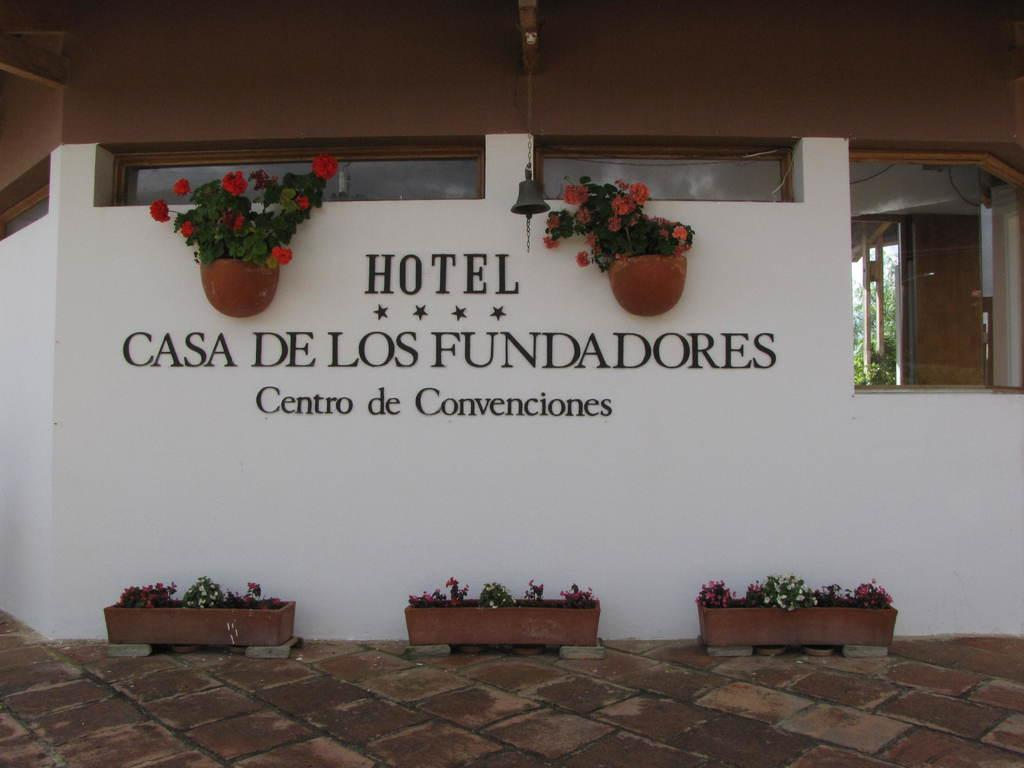What type of plants are in the image? There are plants with pots and flowers in the image. What can be seen on the wall in the image? There is text on a wall in the image. What architectural features are visible in the image? There are windows and a door in the image. What can be seen through the windows in the image? Leaves are visible through the windows. How many bricks can be seen sparking in the image? There are no bricks or sparking visible in the image. 